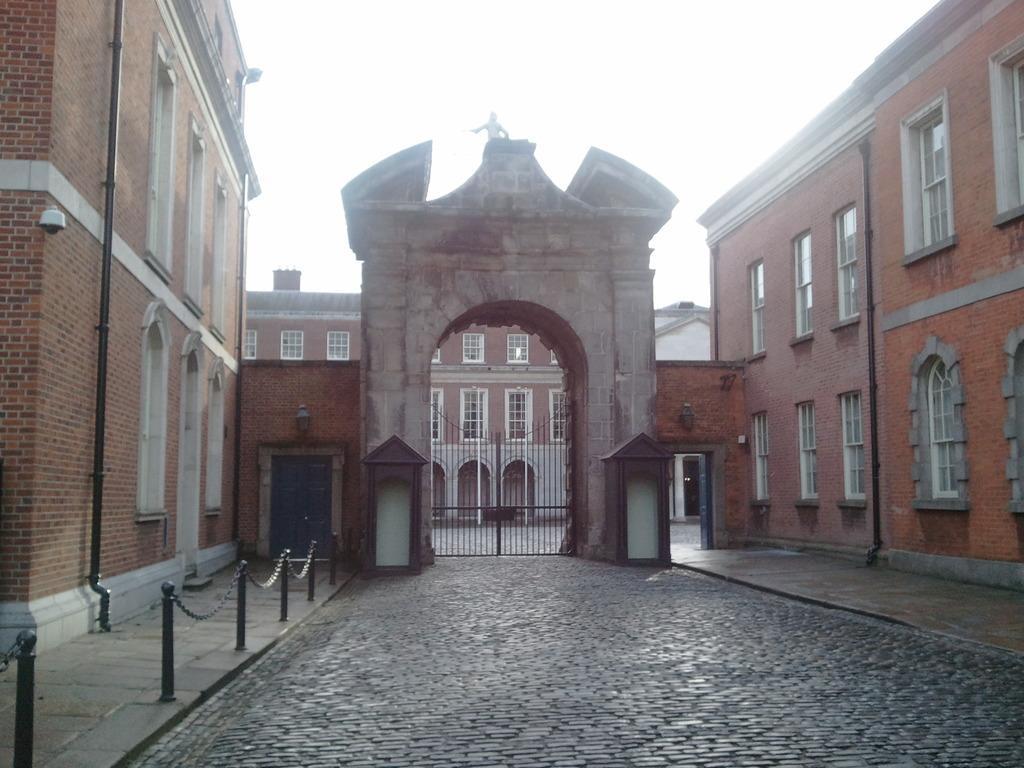How would you summarize this image in a sentence or two? In this image we can see the buildings with windows, doors and gate. And there are poles, pipelines, ground and sky in the background. 